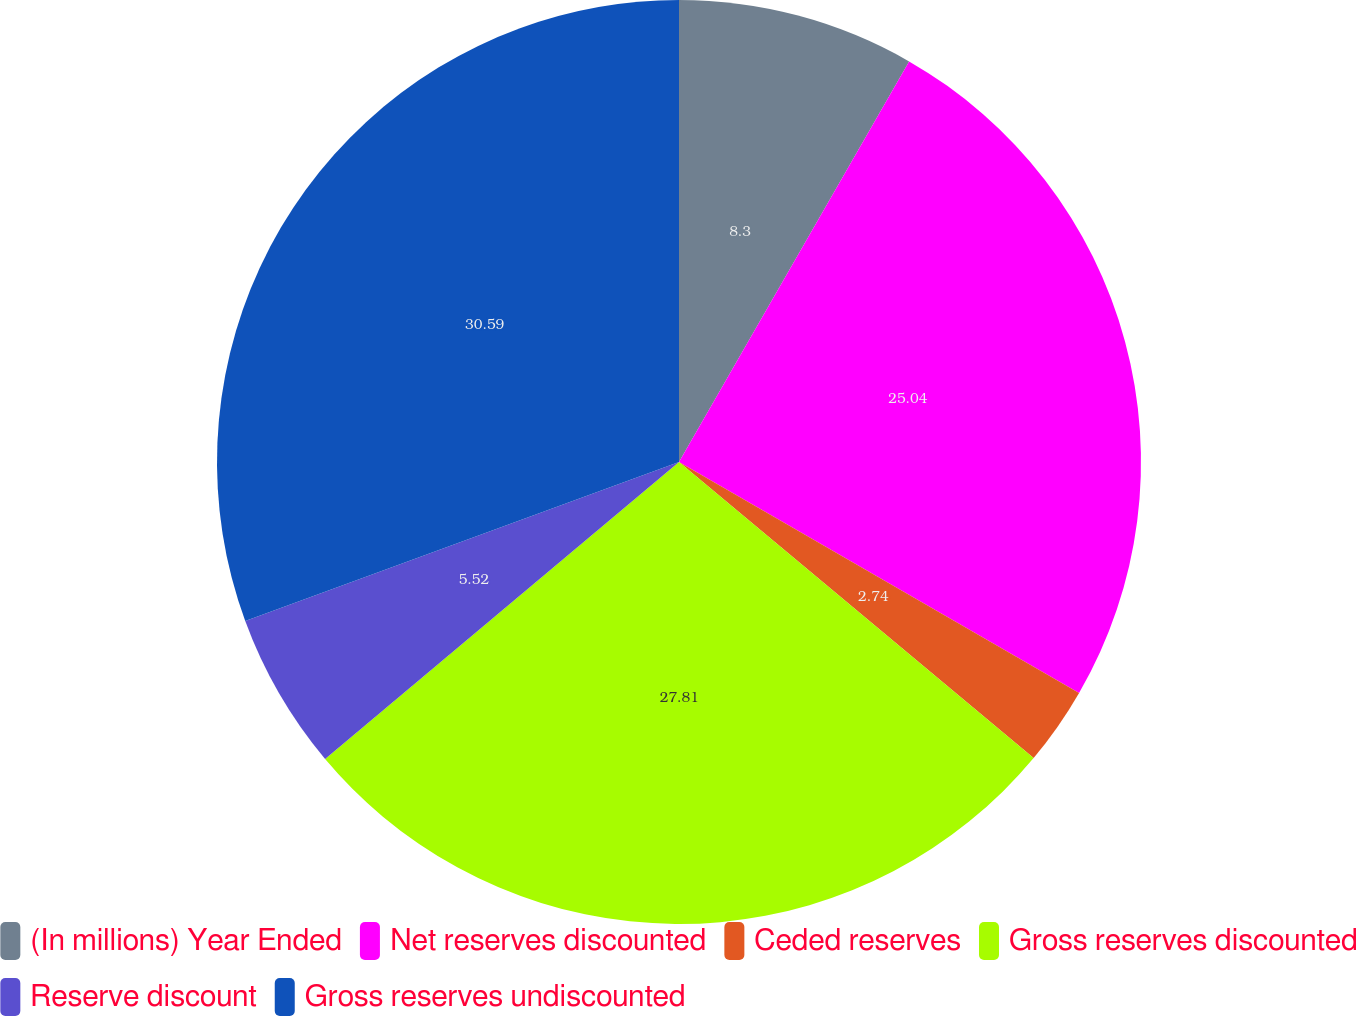Convert chart. <chart><loc_0><loc_0><loc_500><loc_500><pie_chart><fcel>(In millions) Year Ended<fcel>Net reserves discounted<fcel>Ceded reserves<fcel>Gross reserves discounted<fcel>Reserve discount<fcel>Gross reserves undiscounted<nl><fcel>8.3%<fcel>25.04%<fcel>2.74%<fcel>27.82%<fcel>5.52%<fcel>30.6%<nl></chart> 